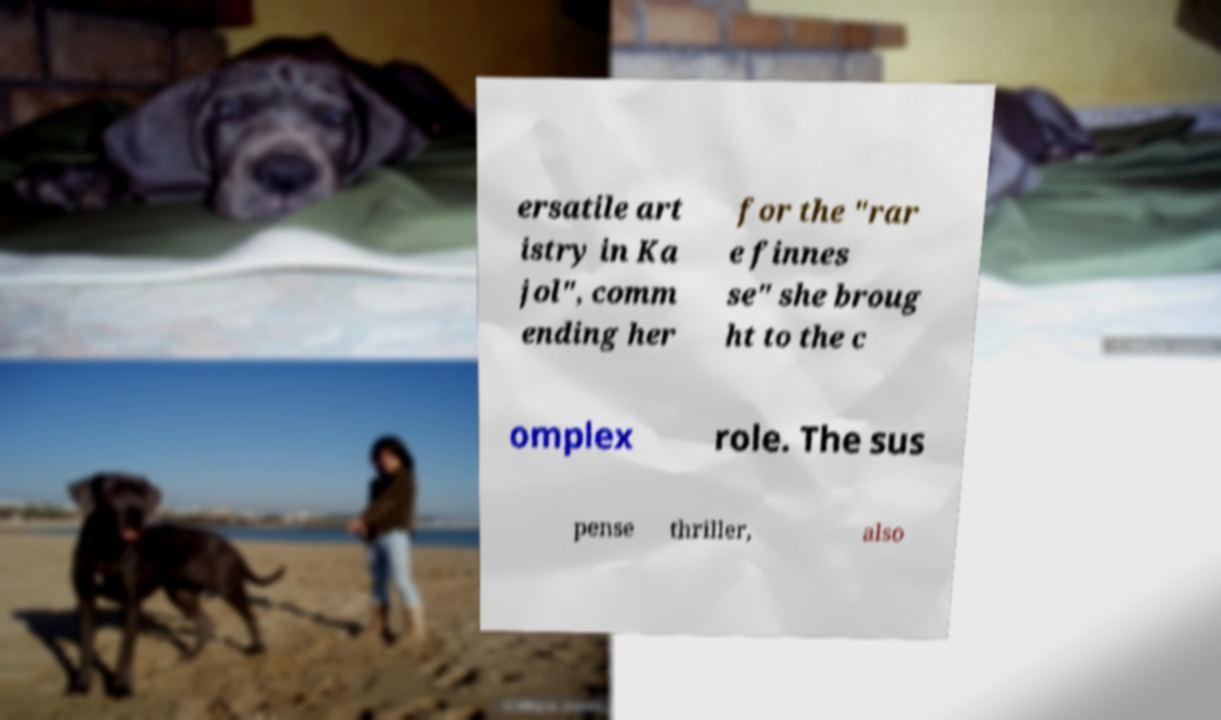What messages or text are displayed in this image? I need them in a readable, typed format. ersatile art istry in Ka jol", comm ending her for the "rar e finnes se" she broug ht to the c omplex role. The sus pense thriller, also 